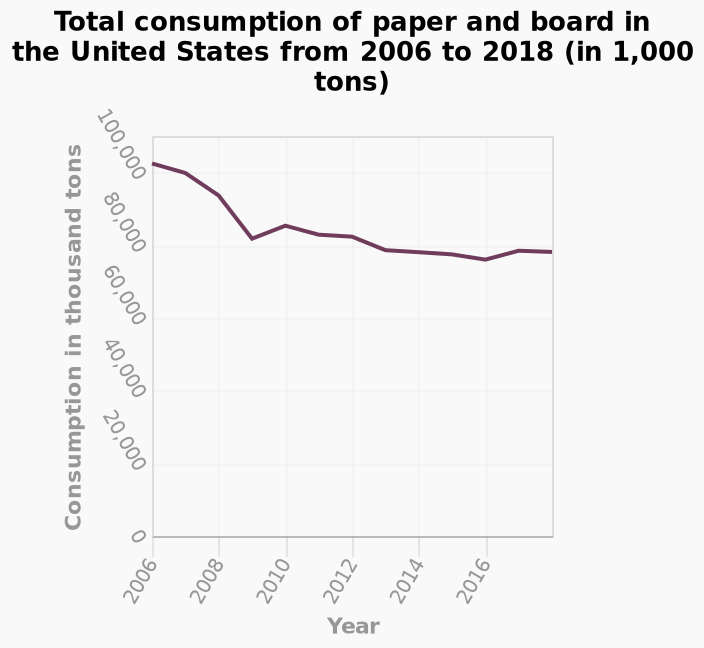<image>
What is the minimum year represented on the x-axis? The minimum year represented on the x-axis is 2006. Describe the following image in detail Here a line graph is named Total consumption of paper and board in the United States from 2006 to 2018 (in 1,000 tons). The x-axis shows Year as linear scale with a minimum of 2006 and a maximum of 2016 while the y-axis shows Consumption in thousand tons on linear scale of range 0 to 100,000. In which year was the consumption of paper and board in the United States less than in 2018?  The consumption of paper and board in the United States was less in 2006 than in 2018. What is the maximum year represented on the x-axis? The maximum year represented on the x-axis is 2016. 